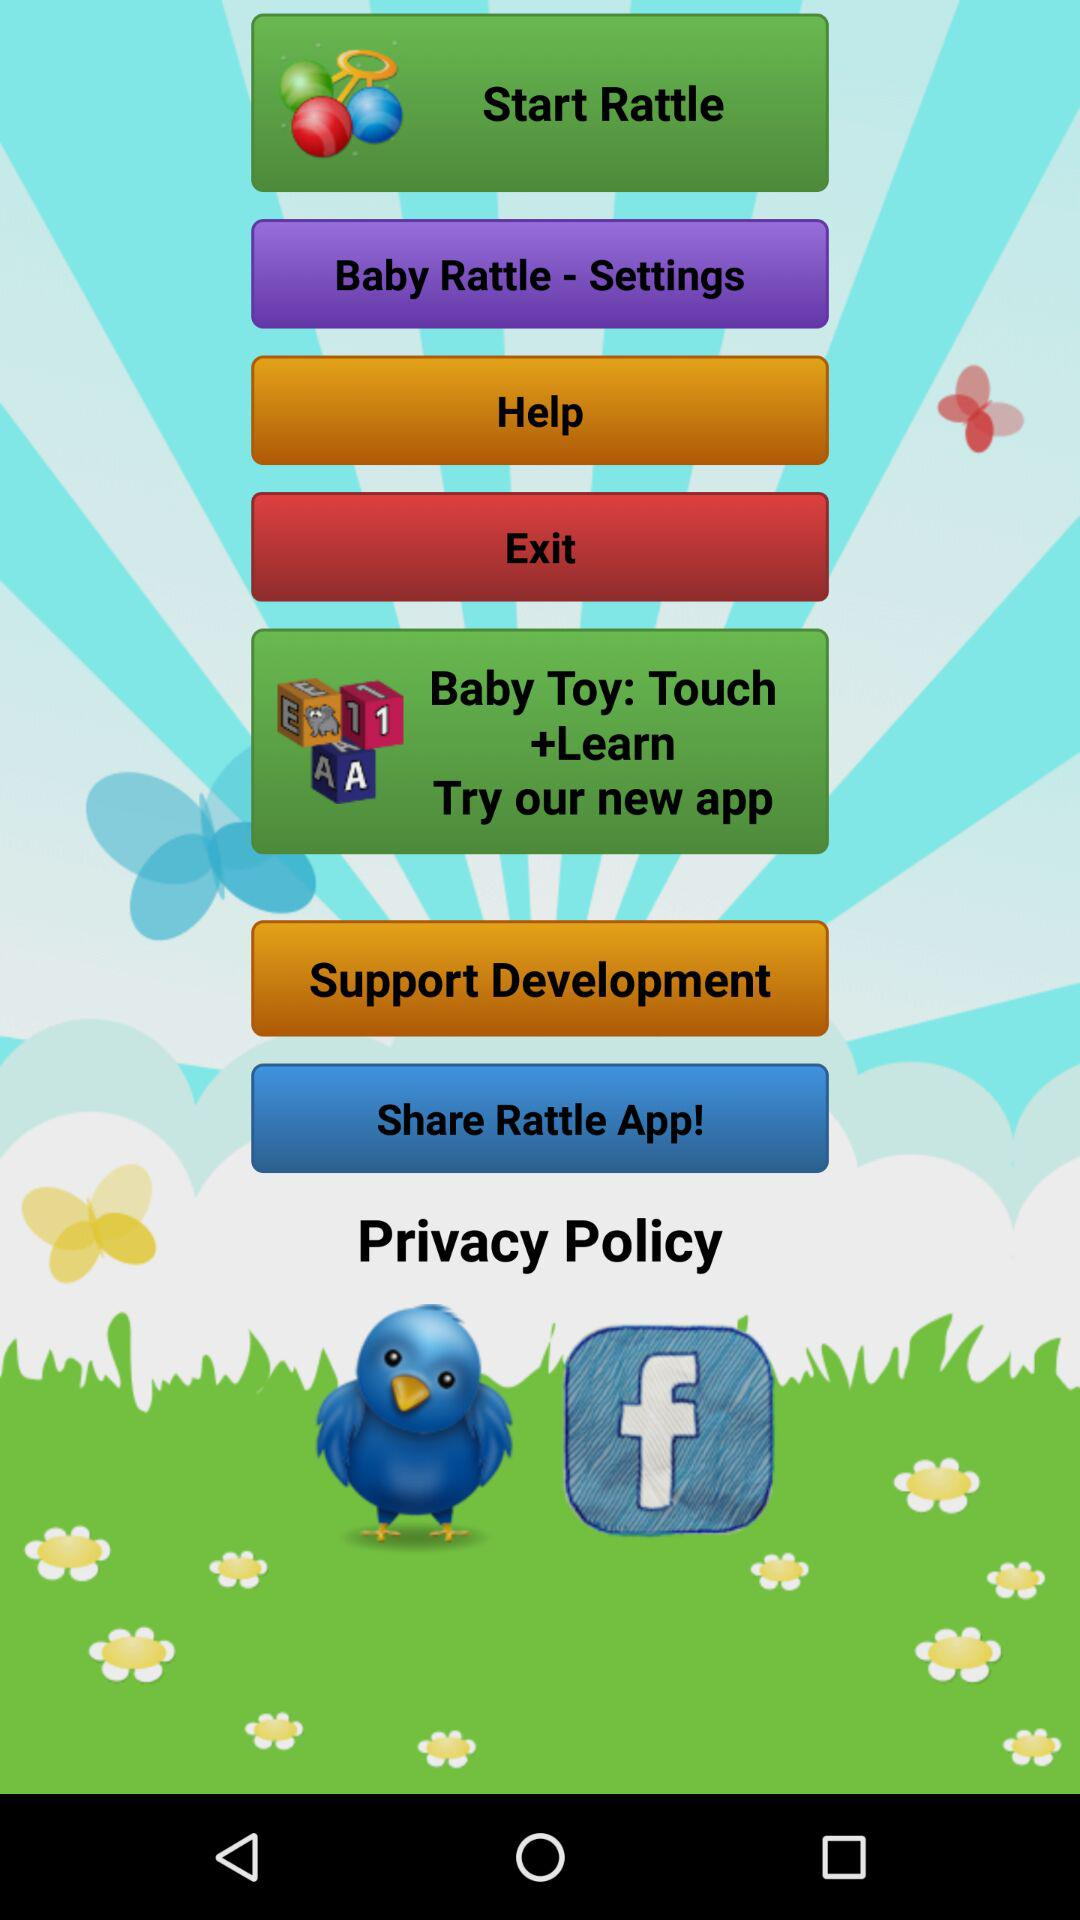Can we share rattle app?
When the provided information is insufficient, respond with <no answer>. <no answer> 